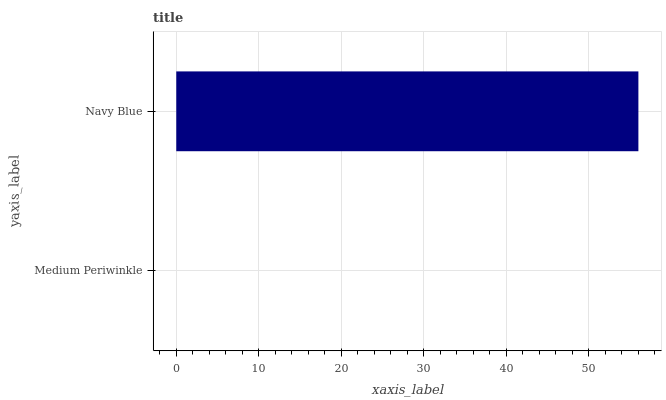Is Medium Periwinkle the minimum?
Answer yes or no. Yes. Is Navy Blue the maximum?
Answer yes or no. Yes. Is Navy Blue the minimum?
Answer yes or no. No. Is Navy Blue greater than Medium Periwinkle?
Answer yes or no. Yes. Is Medium Periwinkle less than Navy Blue?
Answer yes or no. Yes. Is Medium Periwinkle greater than Navy Blue?
Answer yes or no. No. Is Navy Blue less than Medium Periwinkle?
Answer yes or no. No. Is Navy Blue the high median?
Answer yes or no. Yes. Is Medium Periwinkle the low median?
Answer yes or no. Yes. Is Medium Periwinkle the high median?
Answer yes or no. No. Is Navy Blue the low median?
Answer yes or no. No. 